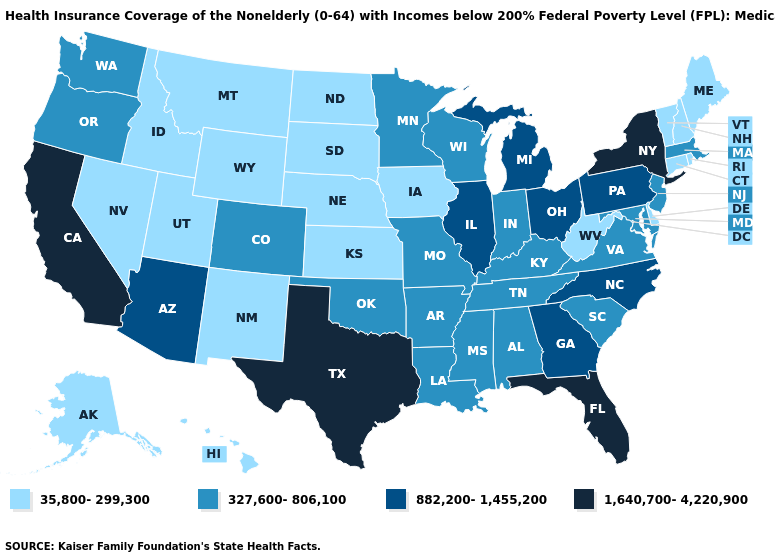Does Wisconsin have a lower value than Arizona?
Answer briefly. Yes. Name the states that have a value in the range 882,200-1,455,200?
Quick response, please. Arizona, Georgia, Illinois, Michigan, North Carolina, Ohio, Pennsylvania. What is the value of Hawaii?
Be succinct. 35,800-299,300. What is the value of Pennsylvania?
Quick response, please. 882,200-1,455,200. What is the highest value in the South ?
Short answer required. 1,640,700-4,220,900. What is the value of Massachusetts?
Keep it brief. 327,600-806,100. What is the value of Kentucky?
Short answer required. 327,600-806,100. What is the highest value in the West ?
Write a very short answer. 1,640,700-4,220,900. Name the states that have a value in the range 35,800-299,300?
Keep it brief. Alaska, Connecticut, Delaware, Hawaii, Idaho, Iowa, Kansas, Maine, Montana, Nebraska, Nevada, New Hampshire, New Mexico, North Dakota, Rhode Island, South Dakota, Utah, Vermont, West Virginia, Wyoming. Name the states that have a value in the range 327,600-806,100?
Keep it brief. Alabama, Arkansas, Colorado, Indiana, Kentucky, Louisiana, Maryland, Massachusetts, Minnesota, Mississippi, Missouri, New Jersey, Oklahoma, Oregon, South Carolina, Tennessee, Virginia, Washington, Wisconsin. Name the states that have a value in the range 882,200-1,455,200?
Short answer required. Arizona, Georgia, Illinois, Michigan, North Carolina, Ohio, Pennsylvania. What is the value of Massachusetts?
Short answer required. 327,600-806,100. Is the legend a continuous bar?
Give a very brief answer. No. Does California have the highest value in the USA?
Quick response, please. Yes. 